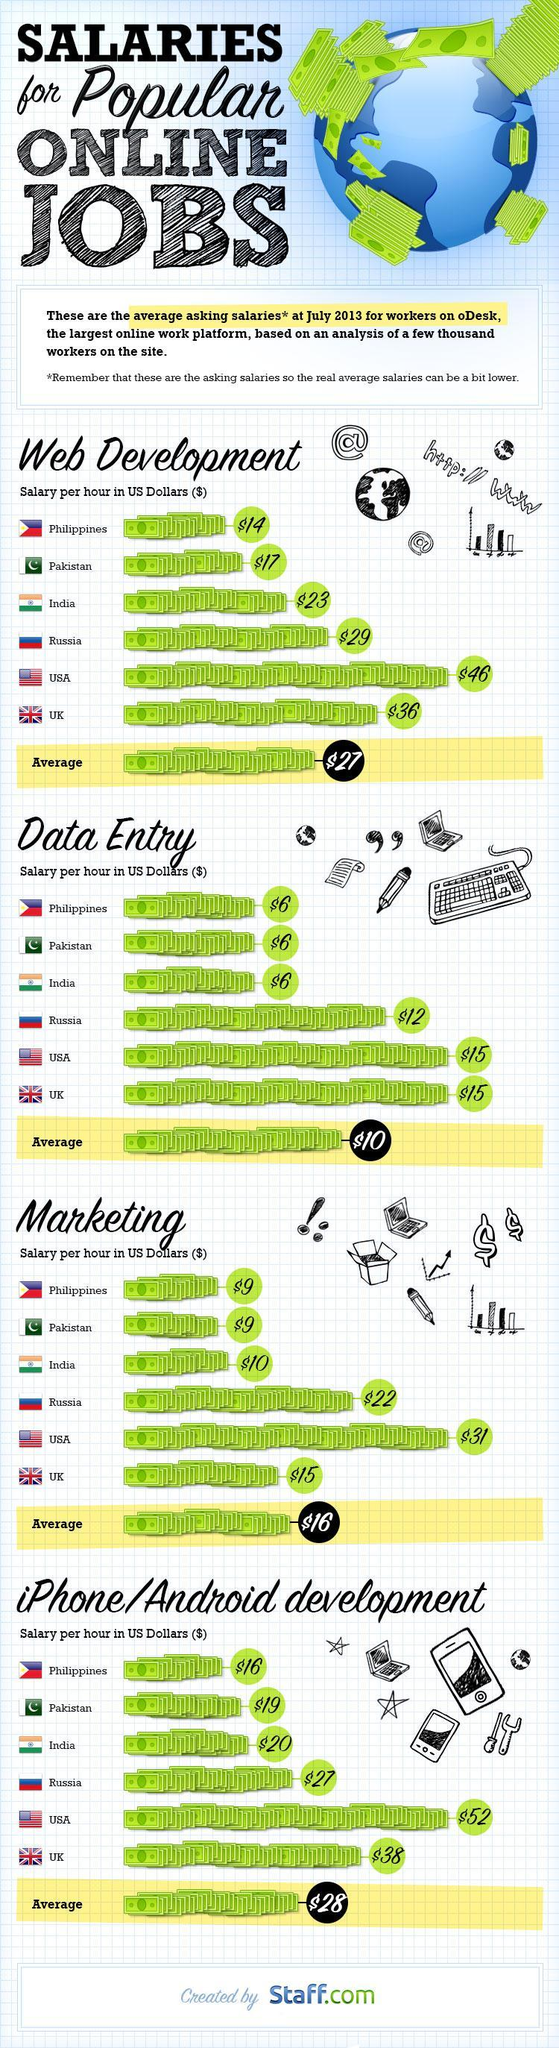How many companies have been compared in the document ?
Answer the question with a short phrase. 6 Which country is paid the least salary per hour for web development, data entry, marketing and Android development ? Phillipines Which country Pakistan or India gets a lower pay for all the four categories of online jobs ? Pakistan Calculate the total of the average pay for all categories of online jobs? $ 81 